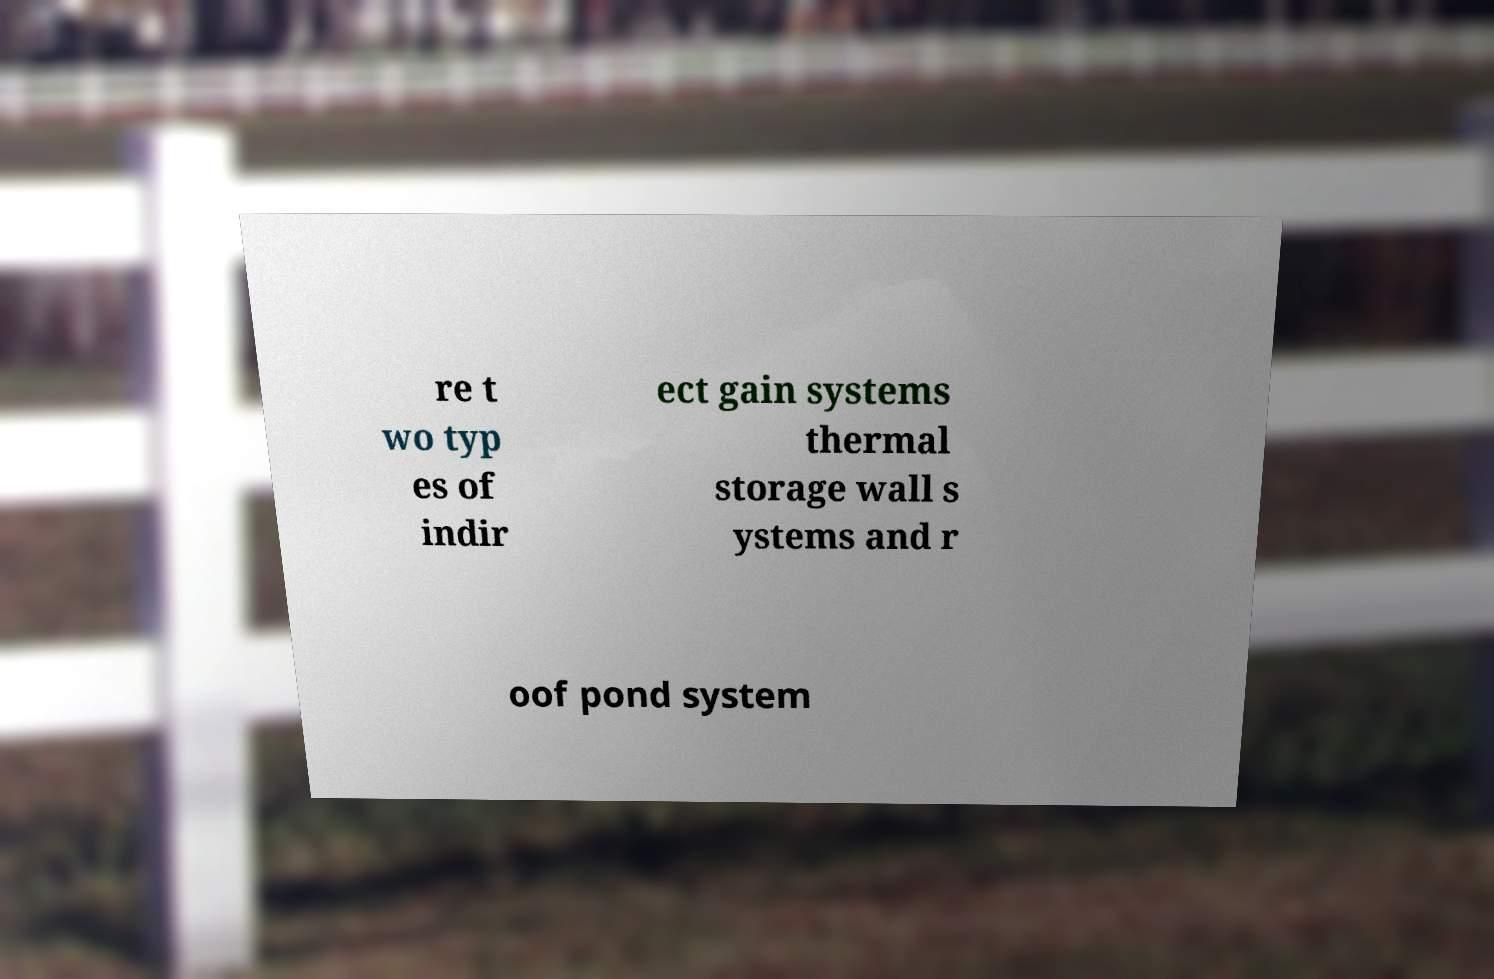For documentation purposes, I need the text within this image transcribed. Could you provide that? re t wo typ es of indir ect gain systems thermal storage wall s ystems and r oof pond system 